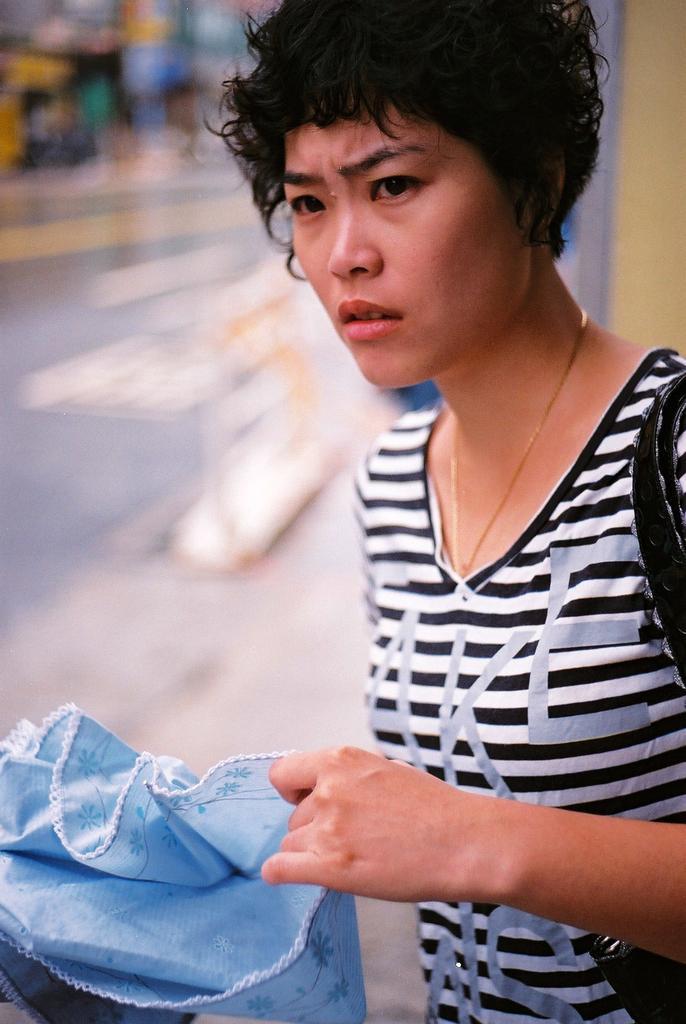Could you give a brief overview of what you see in this image? On the right side, there is a woman in a t-shirt, wearing a handbag and holding a cloth. And the background is blurred. 